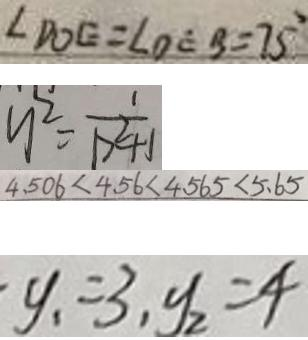Convert formula to latex. <formula><loc_0><loc_0><loc_500><loc_500>\angle D O E = \angle O E B = 7 5 ^ { \circ } 
 y ^ { 2 } = \frac { 1 } { P ^ { 2 } + 1 } 
 4 . 5 0 6 < 4 . 5 6 < 4 . 5 6 5 < 5 . 6 5 
 y _ { 1 } = 3 , y _ { 2 } = 4</formula> 